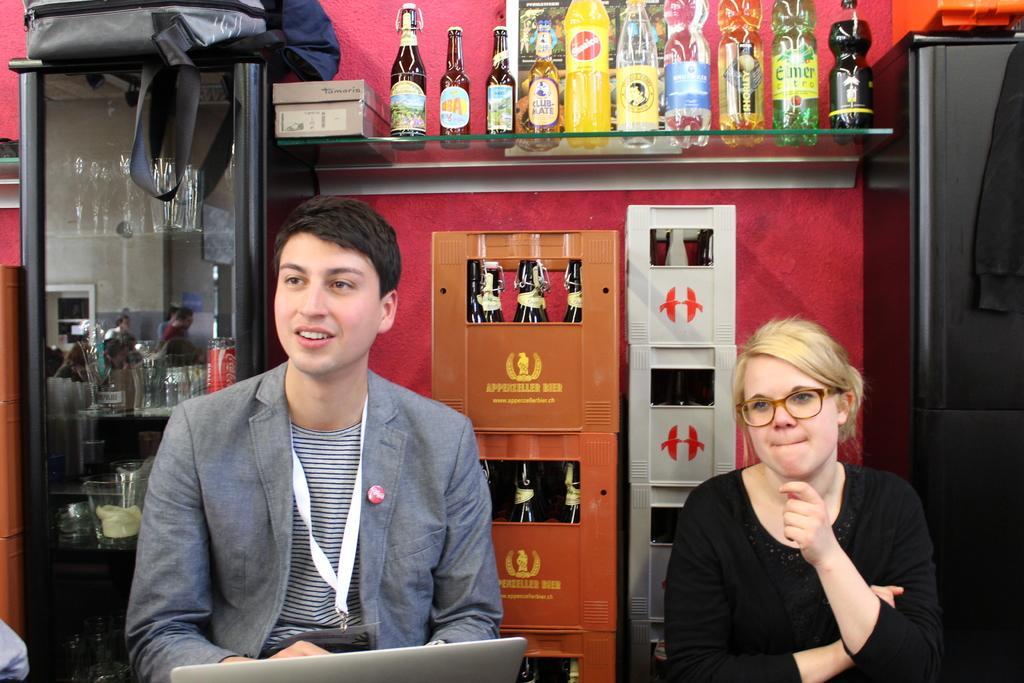How would you summarize this image in a sentence or two? In this picture, we see a man and the women are sitting on the chairs. In front of the man, we see a laptop. Behind them, we see the cool drink cases which are in orange and white color. On the right side, we see the refrigerator and behind that, we see a red wall. At the top, we see a glass rack in which box, glass bottles and the cool drink bottles are placed. On the left side, we see the dressing table on which the bag is placed. This picture might be clicked inside the room. 